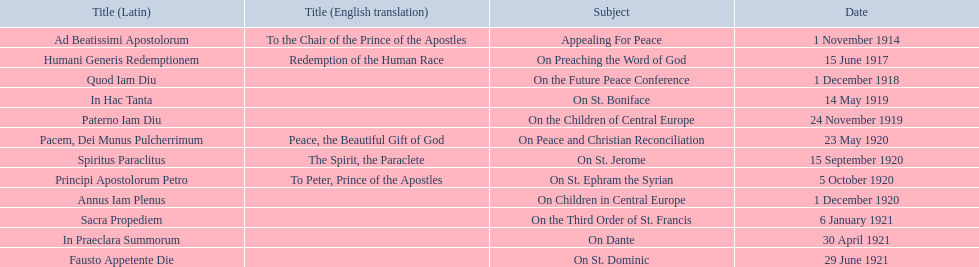What are all the subjects? Appealing For Peace, On Preaching the Word of God, On the Future Peace Conference, On St. Boniface, On the Children of Central Europe, On Peace and Christian Reconciliation, On St. Jerome, On St. Ephram the Syrian, On Children in Central Europe, On the Third Order of St. Francis, On Dante, On St. Dominic. What are their dates? 1 November 1914, 15 June 1917, 1 December 1918, 14 May 1919, 24 November 1919, 23 May 1920, 15 September 1920, 5 October 1920, 1 December 1920, 6 January 1921, 30 April 1921, 29 June 1921. Which subject's date belongs to 23 may 1920? On Peace and Christian Reconciliation. 